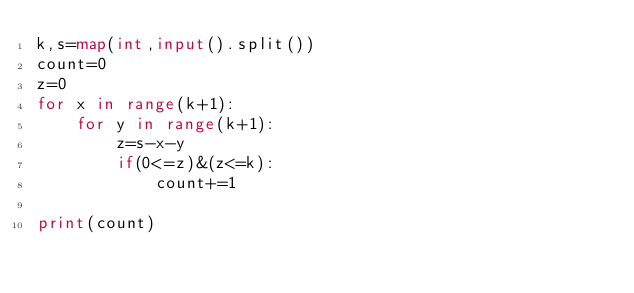<code> <loc_0><loc_0><loc_500><loc_500><_Python_>k,s=map(int,input().split())
count=0
z=0
for x in range(k+1):
    for y in range(k+1):
        z=s-x-y
        if(0<=z)&(z<=k):
            count+=1
            
print(count)
</code> 